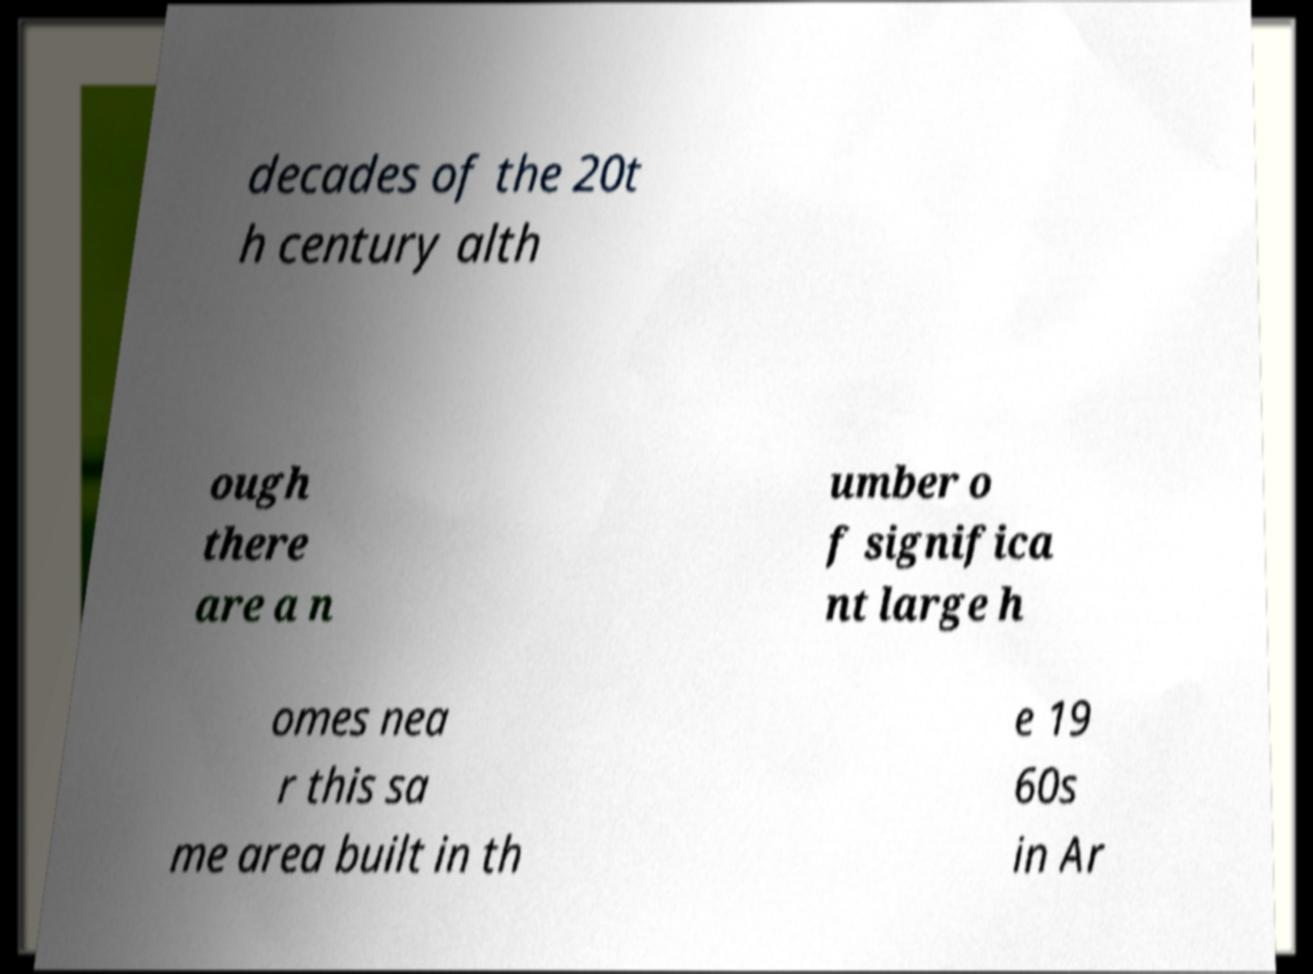Can you read and provide the text displayed in the image?This photo seems to have some interesting text. Can you extract and type it out for me? decades of the 20t h century alth ough there are a n umber o f significa nt large h omes nea r this sa me area built in th e 19 60s in Ar 